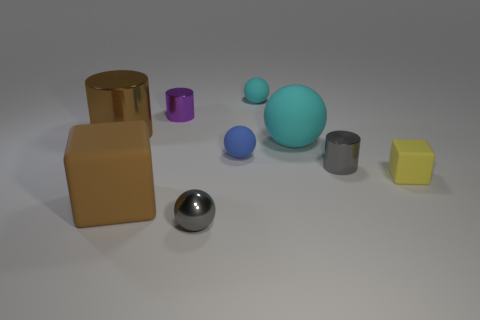Is there anything else of the same color as the large sphere?
Provide a short and direct response. Yes. What is the color of the large rubber object in front of the block right of the metallic ball?
Your response must be concise. Brown. How many tiny objects are cylinders or red rubber objects?
Offer a terse response. 2. There is a big thing that is the same shape as the small blue rubber thing; what material is it?
Ensure brevity in your answer.  Rubber. What color is the large block?
Your answer should be very brief. Brown. Do the big matte block and the big cylinder have the same color?
Provide a short and direct response. Yes. There is a small cylinder on the right side of the gray metallic ball; what number of small gray objects are right of it?
Your answer should be compact. 0. What is the size of the metal thing that is to the left of the tiny blue ball and right of the purple metal object?
Provide a succinct answer. Small. There is a brown object in front of the tiny gray cylinder; what is it made of?
Ensure brevity in your answer.  Rubber. Are there any yellow rubber objects that have the same shape as the big brown rubber thing?
Offer a very short reply. Yes. 